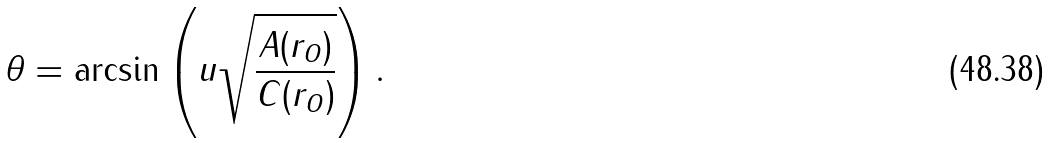<formula> <loc_0><loc_0><loc_500><loc_500>\theta = \arcsin \left ( u \sqrt { \frac { A ( r _ { O } ) } { C ( r _ { O } ) } } \right ) .</formula> 